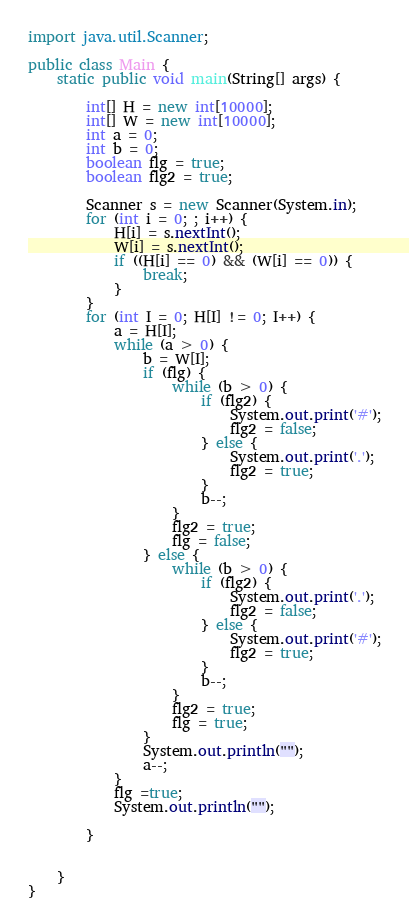Convert code to text. <code><loc_0><loc_0><loc_500><loc_500><_Java_>
import java.util.Scanner;

public class Main {
    static public void main(String[] args) {

        int[] H = new int[10000];
        int[] W = new int[10000];
        int a = 0;
        int b = 0;
        boolean flg = true;
        boolean flg2 = true;

        Scanner s = new Scanner(System.in);
        for (int i = 0; ; i++) {
            H[i] = s.nextInt();
            W[i] = s.nextInt();
            if ((H[i] == 0) && (W[i] == 0)) {
                break;
            }
        }
        for (int I = 0; H[I] != 0; I++) {
            a = H[I];
            while (a > 0) {
                b = W[I];
                if (flg) {
                    while (b > 0) {
                        if (flg2) {
                            System.out.print('#');
                            flg2 = false;
                        } else {
                            System.out.print('.');
                            flg2 = true;
                        }
                        b--;
                    }
                    flg2 = true;
                    flg = false;
                } else {
                    while (b > 0) {
                        if (flg2) {
                            System.out.print('.');
                            flg2 = false;
                        } else {
                            System.out.print('#');
                            flg2 = true;
                        }
                        b--;
                    }
                    flg2 = true;
                    flg = true;
                }
                System.out.println("");
                a--;
            }
            flg =true;
            System.out.println("");

        }


    }
}

</code> 